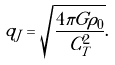Convert formula to latex. <formula><loc_0><loc_0><loc_500><loc_500>q _ { J } = \sqrt { \frac { 4 \pi G \rho _ { 0 } } { C ^ { 2 } _ { T } } } .</formula> 